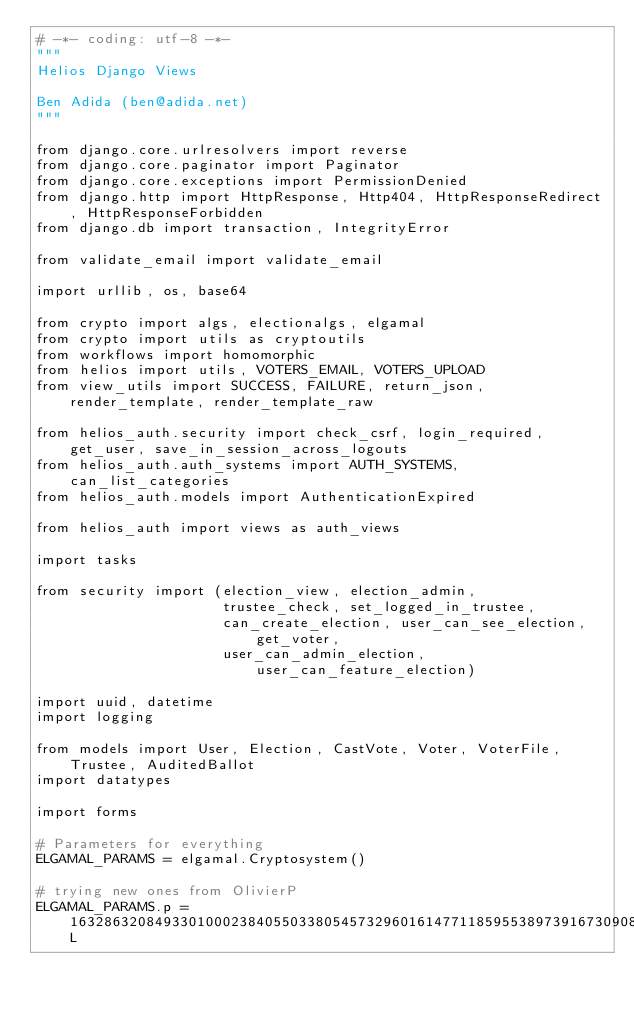Convert code to text. <code><loc_0><loc_0><loc_500><loc_500><_Python_># -*- coding: utf-8 -*-
"""
Helios Django Views

Ben Adida (ben@adida.net)
"""

from django.core.urlresolvers import reverse
from django.core.paginator import Paginator
from django.core.exceptions import PermissionDenied
from django.http import HttpResponse, Http404, HttpResponseRedirect, HttpResponseForbidden
from django.db import transaction, IntegrityError

from validate_email import validate_email

import urllib, os, base64

from crypto import algs, electionalgs, elgamal
from crypto import utils as cryptoutils
from workflows import homomorphic
from helios import utils, VOTERS_EMAIL, VOTERS_UPLOAD
from view_utils import SUCCESS, FAILURE, return_json, render_template, render_template_raw

from helios_auth.security import check_csrf, login_required, get_user, save_in_session_across_logouts
from helios_auth.auth_systems import AUTH_SYSTEMS, can_list_categories
from helios_auth.models import AuthenticationExpired

from helios_auth import views as auth_views

import tasks

from security import (election_view, election_admin,
                      trustee_check, set_logged_in_trustee,
                      can_create_election, user_can_see_election, get_voter,
                      user_can_admin_election, user_can_feature_election)

import uuid, datetime
import logging

from models import User, Election, CastVote, Voter, VoterFile, Trustee, AuditedBallot
import datatypes

import forms

# Parameters for everything
ELGAMAL_PARAMS = elgamal.Cryptosystem()

# trying new ones from OlivierP
ELGAMAL_PARAMS.p = 16328632084933010002384055033805457329601614771185955389739167309086214800406465799038583634953752941675645562182498120750264980492381375579367675648771293800310370964745767014243638518442553823973482995267304044326777047662957480269391322789378384619428596446446984694306187644767462460965622580087564339212631775817895958409016676398975671266179637898557687317076177218843233150695157881061257053019133078545928983562221396313169622475509818442661047018436264806901023966236718367204710755935899013750306107738002364137917426595737403871114187750804346564731250609196846638183903982387884578266136503697493474682071L</code> 